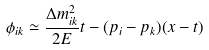<formula> <loc_0><loc_0><loc_500><loc_500>\phi _ { i k } \simeq \frac { \Delta m ^ { 2 } _ { i k } } { 2 E } t - ( p _ { i } - p _ { k } ) ( x - t )</formula> 